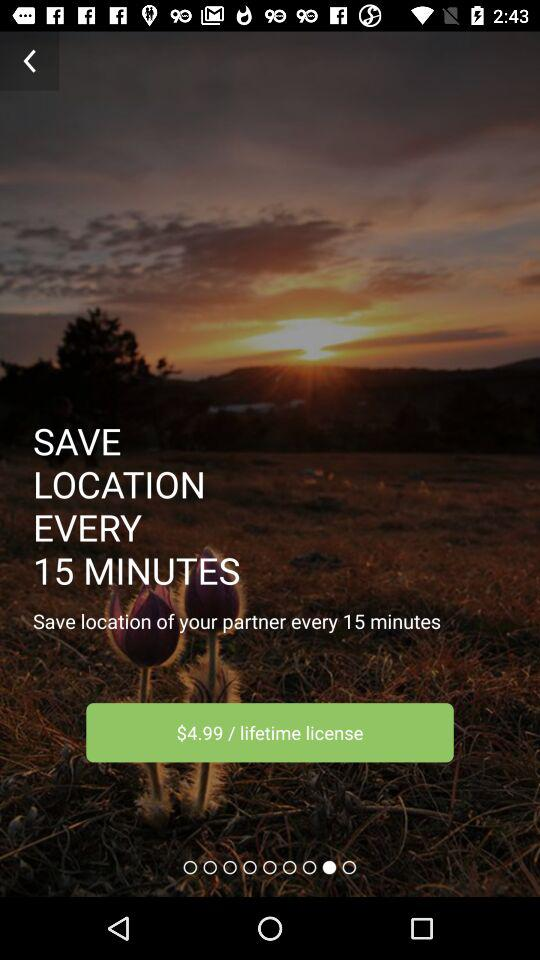What is the price? The price is $4.99. 